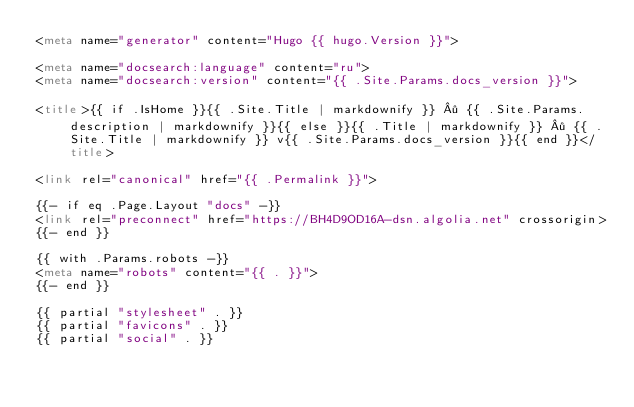<code> <loc_0><loc_0><loc_500><loc_500><_HTML_><meta name="generator" content="Hugo {{ hugo.Version }}">

<meta name="docsearch:language" content="ru">
<meta name="docsearch:version" content="{{ .Site.Params.docs_version }}">

<title>{{ if .IsHome }}{{ .Site.Title | markdownify }} · {{ .Site.Params.description | markdownify }}{{ else }}{{ .Title | markdownify }} · {{ .Site.Title | markdownify }} v{{ .Site.Params.docs_version }}{{ end }}</title>

<link rel="canonical" href="{{ .Permalink }}">

{{- if eq .Page.Layout "docs" -}}
<link rel="preconnect" href="https://BH4D9OD16A-dsn.algolia.net" crossorigin>
{{- end }}

{{ with .Params.robots -}}
<meta name="robots" content="{{ . }}">
{{- end }}

{{ partial "stylesheet" . }}
{{ partial "favicons" . }}
{{ partial "social" . }}
</code> 